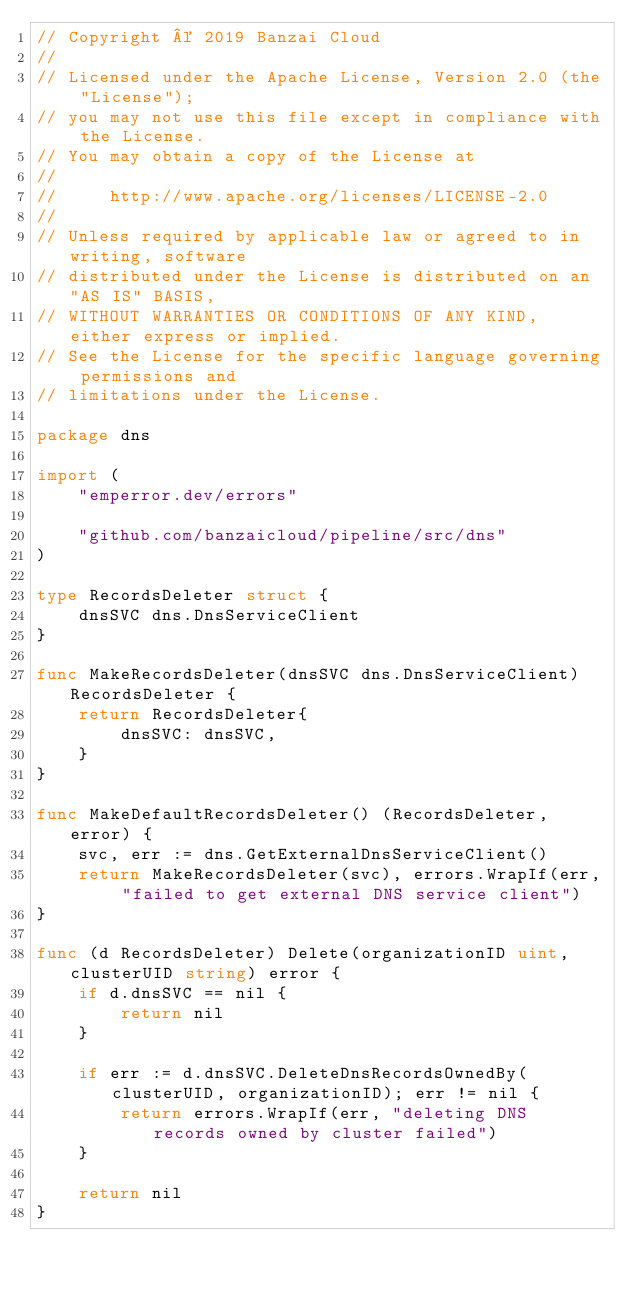<code> <loc_0><loc_0><loc_500><loc_500><_Go_>// Copyright © 2019 Banzai Cloud
//
// Licensed under the Apache License, Version 2.0 (the "License");
// you may not use this file except in compliance with the License.
// You may obtain a copy of the License at
//
//     http://www.apache.org/licenses/LICENSE-2.0
//
// Unless required by applicable law or agreed to in writing, software
// distributed under the License is distributed on an "AS IS" BASIS,
// WITHOUT WARRANTIES OR CONDITIONS OF ANY KIND, either express or implied.
// See the License for the specific language governing permissions and
// limitations under the License.

package dns

import (
	"emperror.dev/errors"

	"github.com/banzaicloud/pipeline/src/dns"
)

type RecordsDeleter struct {
	dnsSVC dns.DnsServiceClient
}

func MakeRecordsDeleter(dnsSVC dns.DnsServiceClient) RecordsDeleter {
	return RecordsDeleter{
		dnsSVC: dnsSVC,
	}
}

func MakeDefaultRecordsDeleter() (RecordsDeleter, error) {
	svc, err := dns.GetExternalDnsServiceClient()
	return MakeRecordsDeleter(svc), errors.WrapIf(err, "failed to get external DNS service client")
}

func (d RecordsDeleter) Delete(organizationID uint, clusterUID string) error {
	if d.dnsSVC == nil {
		return nil
	}

	if err := d.dnsSVC.DeleteDnsRecordsOwnedBy(clusterUID, organizationID); err != nil {
		return errors.WrapIf(err, "deleting DNS records owned by cluster failed")
	}

	return nil
}
</code> 